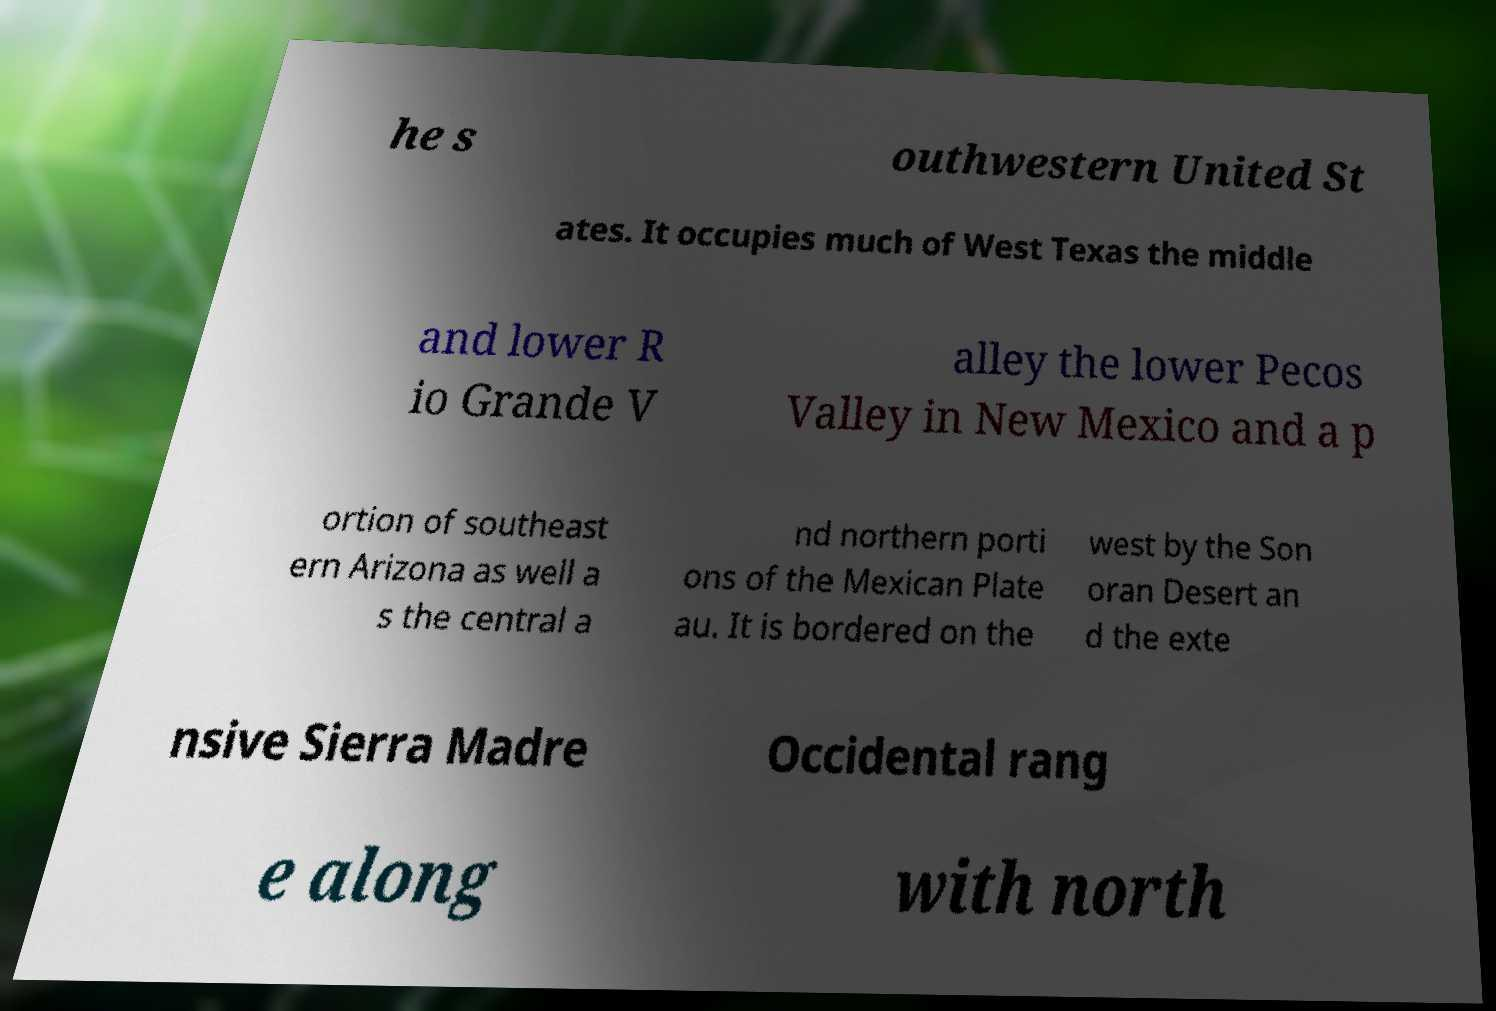Please identify and transcribe the text found in this image. he s outhwestern United St ates. It occupies much of West Texas the middle and lower R io Grande V alley the lower Pecos Valley in New Mexico and a p ortion of southeast ern Arizona as well a s the central a nd northern porti ons of the Mexican Plate au. It is bordered on the west by the Son oran Desert an d the exte nsive Sierra Madre Occidental rang e along with north 